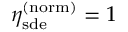Convert formula to latex. <formula><loc_0><loc_0><loc_500><loc_500>\eta _ { s d e } ^ { ( n o r m ) } = 1</formula> 